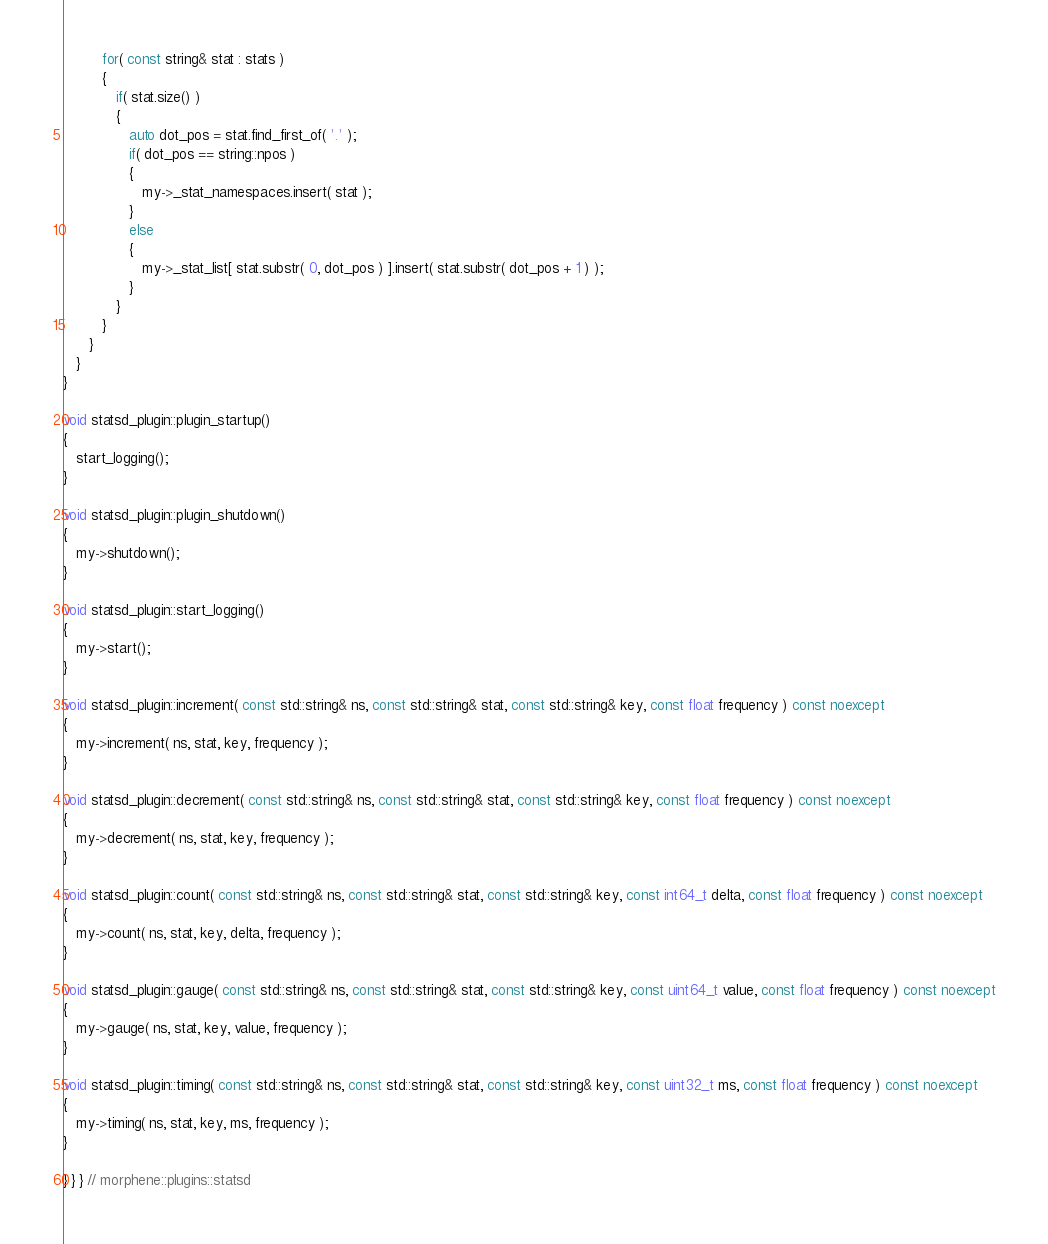Convert code to text. <code><loc_0><loc_0><loc_500><loc_500><_C++_>
         for( const string& stat : stats )
         {
            if( stat.size() )
            {
               auto dot_pos = stat.find_first_of( '.' );
               if( dot_pos == string::npos )
               {
                  my->_stat_namespaces.insert( stat );
               }
               else
               {
                  my->_stat_list[ stat.substr( 0, dot_pos ) ].insert( stat.substr( dot_pos + 1 ) );
               }
            }
         }
      }
   }
}

void statsd_plugin::plugin_startup()
{
   start_logging();
}

void statsd_plugin::plugin_shutdown()
{
   my->shutdown();
}

void statsd_plugin::start_logging()
{
   my->start();
}

void statsd_plugin::increment( const std::string& ns, const std::string& stat, const std::string& key, const float frequency ) const noexcept
{
   my->increment( ns, stat, key, frequency );
}

void statsd_plugin::decrement( const std::string& ns, const std::string& stat, const std::string& key, const float frequency ) const noexcept
{
   my->decrement( ns, stat, key, frequency );
}

void statsd_plugin::count( const std::string& ns, const std::string& stat, const std::string& key, const int64_t delta, const float frequency ) const noexcept
{
   my->count( ns, stat, key, delta, frequency );
}

void statsd_plugin::gauge( const std::string& ns, const std::string& stat, const std::string& key, const uint64_t value, const float frequency ) const noexcept
{
   my->gauge( ns, stat, key, value, frequency );
}

void statsd_plugin::timing( const std::string& ns, const std::string& stat, const std::string& key, const uint32_t ms, const float frequency ) const noexcept
{
   my->timing( ns, stat, key, ms, frequency );
}

} } } // morphene::plugins::statsd
</code> 